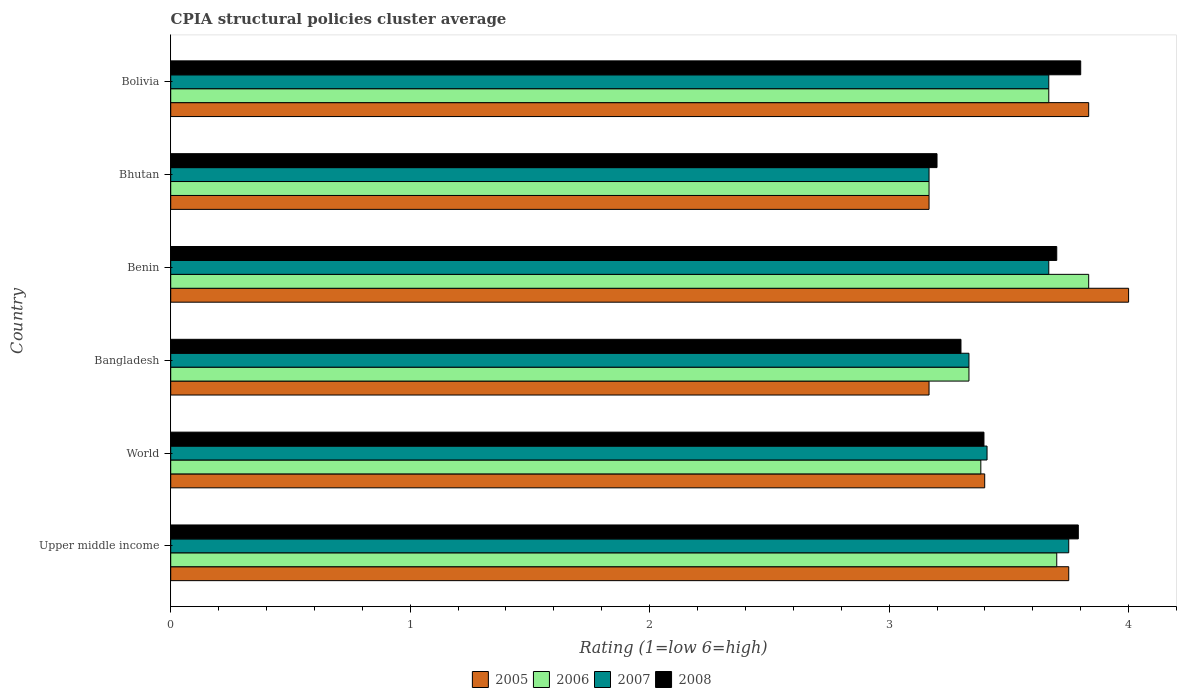How many groups of bars are there?
Offer a very short reply. 6. Are the number of bars on each tick of the Y-axis equal?
Offer a terse response. Yes. How many bars are there on the 5th tick from the top?
Provide a succinct answer. 4. What is the label of the 3rd group of bars from the top?
Give a very brief answer. Benin. In how many cases, is the number of bars for a given country not equal to the number of legend labels?
Your answer should be very brief. 0. What is the CPIA rating in 2005 in Bolivia?
Your answer should be compact. 3.83. Across all countries, what is the maximum CPIA rating in 2007?
Make the answer very short. 3.75. Across all countries, what is the minimum CPIA rating in 2006?
Keep it short and to the point. 3.17. In which country was the CPIA rating in 2006 maximum?
Offer a very short reply. Benin. In which country was the CPIA rating in 2008 minimum?
Offer a very short reply. Bhutan. What is the total CPIA rating in 2008 in the graph?
Ensure brevity in your answer.  21.19. What is the difference between the CPIA rating in 2005 in Bhutan and that in Bolivia?
Ensure brevity in your answer.  -0.67. What is the difference between the CPIA rating in 2007 in Bhutan and the CPIA rating in 2005 in Upper middle income?
Your response must be concise. -0.58. What is the average CPIA rating in 2005 per country?
Provide a short and direct response. 3.55. What is the difference between the CPIA rating in 2006 and CPIA rating in 2008 in World?
Provide a succinct answer. -0.01. What is the ratio of the CPIA rating in 2007 in Bangladesh to that in Bolivia?
Ensure brevity in your answer.  0.91. Is the CPIA rating in 2006 in Bolivia less than that in Upper middle income?
Your response must be concise. Yes. What is the difference between the highest and the second highest CPIA rating in 2008?
Give a very brief answer. 0.01. What is the difference between the highest and the lowest CPIA rating in 2007?
Provide a succinct answer. 0.58. Is the sum of the CPIA rating in 2006 in Bhutan and Bolivia greater than the maximum CPIA rating in 2008 across all countries?
Your response must be concise. Yes. What does the 4th bar from the bottom in Bhutan represents?
Keep it short and to the point. 2008. Are all the bars in the graph horizontal?
Make the answer very short. Yes. How many countries are there in the graph?
Your answer should be very brief. 6. Does the graph contain grids?
Your answer should be very brief. No. What is the title of the graph?
Provide a succinct answer. CPIA structural policies cluster average. What is the Rating (1=low 6=high) in 2005 in Upper middle income?
Provide a succinct answer. 3.75. What is the Rating (1=low 6=high) of 2006 in Upper middle income?
Your response must be concise. 3.7. What is the Rating (1=low 6=high) of 2007 in Upper middle income?
Offer a very short reply. 3.75. What is the Rating (1=low 6=high) in 2008 in Upper middle income?
Keep it short and to the point. 3.79. What is the Rating (1=low 6=high) in 2005 in World?
Offer a terse response. 3.4. What is the Rating (1=low 6=high) of 2006 in World?
Offer a terse response. 3.38. What is the Rating (1=low 6=high) of 2007 in World?
Make the answer very short. 3.41. What is the Rating (1=low 6=high) of 2008 in World?
Give a very brief answer. 3.4. What is the Rating (1=low 6=high) of 2005 in Bangladesh?
Provide a short and direct response. 3.17. What is the Rating (1=low 6=high) in 2006 in Bangladesh?
Provide a short and direct response. 3.33. What is the Rating (1=low 6=high) in 2007 in Bangladesh?
Your answer should be compact. 3.33. What is the Rating (1=low 6=high) in 2005 in Benin?
Your response must be concise. 4. What is the Rating (1=low 6=high) of 2006 in Benin?
Offer a very short reply. 3.83. What is the Rating (1=low 6=high) in 2007 in Benin?
Give a very brief answer. 3.67. What is the Rating (1=low 6=high) in 2008 in Benin?
Your answer should be very brief. 3.7. What is the Rating (1=low 6=high) of 2005 in Bhutan?
Your answer should be very brief. 3.17. What is the Rating (1=low 6=high) of 2006 in Bhutan?
Make the answer very short. 3.17. What is the Rating (1=low 6=high) in 2007 in Bhutan?
Provide a succinct answer. 3.17. What is the Rating (1=low 6=high) of 2005 in Bolivia?
Offer a terse response. 3.83. What is the Rating (1=low 6=high) of 2006 in Bolivia?
Make the answer very short. 3.67. What is the Rating (1=low 6=high) of 2007 in Bolivia?
Your answer should be compact. 3.67. What is the Rating (1=low 6=high) in 2008 in Bolivia?
Give a very brief answer. 3.8. Across all countries, what is the maximum Rating (1=low 6=high) of 2005?
Make the answer very short. 4. Across all countries, what is the maximum Rating (1=low 6=high) in 2006?
Offer a terse response. 3.83. Across all countries, what is the maximum Rating (1=low 6=high) of 2007?
Provide a succinct answer. 3.75. Across all countries, what is the minimum Rating (1=low 6=high) of 2005?
Provide a short and direct response. 3.17. Across all countries, what is the minimum Rating (1=low 6=high) in 2006?
Offer a very short reply. 3.17. Across all countries, what is the minimum Rating (1=low 6=high) of 2007?
Provide a succinct answer. 3.17. Across all countries, what is the minimum Rating (1=low 6=high) in 2008?
Provide a succinct answer. 3.2. What is the total Rating (1=low 6=high) of 2005 in the graph?
Provide a short and direct response. 21.32. What is the total Rating (1=low 6=high) in 2006 in the graph?
Make the answer very short. 21.08. What is the total Rating (1=low 6=high) of 2007 in the graph?
Ensure brevity in your answer.  20.99. What is the total Rating (1=low 6=high) in 2008 in the graph?
Your answer should be very brief. 21.19. What is the difference between the Rating (1=low 6=high) in 2005 in Upper middle income and that in World?
Offer a very short reply. 0.35. What is the difference between the Rating (1=low 6=high) in 2006 in Upper middle income and that in World?
Your answer should be compact. 0.32. What is the difference between the Rating (1=low 6=high) of 2007 in Upper middle income and that in World?
Ensure brevity in your answer.  0.34. What is the difference between the Rating (1=low 6=high) of 2008 in Upper middle income and that in World?
Keep it short and to the point. 0.39. What is the difference between the Rating (1=low 6=high) of 2005 in Upper middle income and that in Bangladesh?
Make the answer very short. 0.58. What is the difference between the Rating (1=low 6=high) of 2006 in Upper middle income and that in Bangladesh?
Ensure brevity in your answer.  0.37. What is the difference between the Rating (1=low 6=high) of 2007 in Upper middle income and that in Bangladesh?
Give a very brief answer. 0.42. What is the difference between the Rating (1=low 6=high) of 2008 in Upper middle income and that in Bangladesh?
Keep it short and to the point. 0.49. What is the difference between the Rating (1=low 6=high) of 2006 in Upper middle income and that in Benin?
Ensure brevity in your answer.  -0.13. What is the difference between the Rating (1=low 6=high) of 2007 in Upper middle income and that in Benin?
Ensure brevity in your answer.  0.08. What is the difference between the Rating (1=low 6=high) of 2008 in Upper middle income and that in Benin?
Keep it short and to the point. 0.09. What is the difference between the Rating (1=low 6=high) in 2005 in Upper middle income and that in Bhutan?
Your answer should be very brief. 0.58. What is the difference between the Rating (1=low 6=high) of 2006 in Upper middle income and that in Bhutan?
Offer a terse response. 0.53. What is the difference between the Rating (1=low 6=high) in 2007 in Upper middle income and that in Bhutan?
Provide a short and direct response. 0.58. What is the difference between the Rating (1=low 6=high) in 2008 in Upper middle income and that in Bhutan?
Give a very brief answer. 0.59. What is the difference between the Rating (1=low 6=high) in 2005 in Upper middle income and that in Bolivia?
Your answer should be compact. -0.08. What is the difference between the Rating (1=low 6=high) of 2007 in Upper middle income and that in Bolivia?
Your answer should be compact. 0.08. What is the difference between the Rating (1=low 6=high) in 2008 in Upper middle income and that in Bolivia?
Make the answer very short. -0.01. What is the difference between the Rating (1=low 6=high) of 2005 in World and that in Bangladesh?
Provide a short and direct response. 0.23. What is the difference between the Rating (1=low 6=high) of 2006 in World and that in Bangladesh?
Keep it short and to the point. 0.05. What is the difference between the Rating (1=low 6=high) in 2007 in World and that in Bangladesh?
Make the answer very short. 0.08. What is the difference between the Rating (1=low 6=high) in 2008 in World and that in Bangladesh?
Provide a succinct answer. 0.1. What is the difference between the Rating (1=low 6=high) of 2005 in World and that in Benin?
Offer a very short reply. -0.6. What is the difference between the Rating (1=low 6=high) in 2006 in World and that in Benin?
Your answer should be compact. -0.45. What is the difference between the Rating (1=low 6=high) in 2007 in World and that in Benin?
Make the answer very short. -0.26. What is the difference between the Rating (1=low 6=high) in 2008 in World and that in Benin?
Make the answer very short. -0.3. What is the difference between the Rating (1=low 6=high) of 2005 in World and that in Bhutan?
Provide a succinct answer. 0.23. What is the difference between the Rating (1=low 6=high) of 2006 in World and that in Bhutan?
Make the answer very short. 0.22. What is the difference between the Rating (1=low 6=high) in 2007 in World and that in Bhutan?
Ensure brevity in your answer.  0.24. What is the difference between the Rating (1=low 6=high) in 2008 in World and that in Bhutan?
Make the answer very short. 0.2. What is the difference between the Rating (1=low 6=high) in 2005 in World and that in Bolivia?
Your response must be concise. -0.43. What is the difference between the Rating (1=low 6=high) in 2006 in World and that in Bolivia?
Offer a very short reply. -0.28. What is the difference between the Rating (1=low 6=high) of 2007 in World and that in Bolivia?
Your answer should be very brief. -0.26. What is the difference between the Rating (1=low 6=high) of 2008 in World and that in Bolivia?
Your answer should be very brief. -0.4. What is the difference between the Rating (1=low 6=high) in 2006 in Bangladesh and that in Benin?
Offer a very short reply. -0.5. What is the difference between the Rating (1=low 6=high) in 2006 in Bangladesh and that in Bhutan?
Provide a short and direct response. 0.17. What is the difference between the Rating (1=low 6=high) in 2007 in Bangladesh and that in Bhutan?
Keep it short and to the point. 0.17. What is the difference between the Rating (1=low 6=high) in 2008 in Bangladesh and that in Bhutan?
Your answer should be compact. 0.1. What is the difference between the Rating (1=low 6=high) of 2005 in Benin and that in Bhutan?
Make the answer very short. 0.83. What is the difference between the Rating (1=low 6=high) of 2007 in Benin and that in Bhutan?
Your answer should be compact. 0.5. What is the difference between the Rating (1=low 6=high) in 2008 in Benin and that in Bhutan?
Keep it short and to the point. 0.5. What is the difference between the Rating (1=low 6=high) of 2005 in Benin and that in Bolivia?
Your answer should be very brief. 0.17. What is the difference between the Rating (1=low 6=high) in 2007 in Benin and that in Bolivia?
Offer a very short reply. 0. What is the difference between the Rating (1=low 6=high) in 2005 in Bhutan and that in Bolivia?
Offer a terse response. -0.67. What is the difference between the Rating (1=low 6=high) of 2006 in Bhutan and that in Bolivia?
Provide a short and direct response. -0.5. What is the difference between the Rating (1=low 6=high) in 2008 in Bhutan and that in Bolivia?
Provide a short and direct response. -0.6. What is the difference between the Rating (1=low 6=high) of 2005 in Upper middle income and the Rating (1=low 6=high) of 2006 in World?
Your answer should be very brief. 0.37. What is the difference between the Rating (1=low 6=high) of 2005 in Upper middle income and the Rating (1=low 6=high) of 2007 in World?
Your response must be concise. 0.34. What is the difference between the Rating (1=low 6=high) in 2005 in Upper middle income and the Rating (1=low 6=high) in 2008 in World?
Your response must be concise. 0.35. What is the difference between the Rating (1=low 6=high) in 2006 in Upper middle income and the Rating (1=low 6=high) in 2007 in World?
Your answer should be compact. 0.29. What is the difference between the Rating (1=low 6=high) in 2006 in Upper middle income and the Rating (1=low 6=high) in 2008 in World?
Ensure brevity in your answer.  0.3. What is the difference between the Rating (1=low 6=high) in 2007 in Upper middle income and the Rating (1=low 6=high) in 2008 in World?
Offer a very short reply. 0.35. What is the difference between the Rating (1=low 6=high) of 2005 in Upper middle income and the Rating (1=low 6=high) of 2006 in Bangladesh?
Make the answer very short. 0.42. What is the difference between the Rating (1=low 6=high) of 2005 in Upper middle income and the Rating (1=low 6=high) of 2007 in Bangladesh?
Keep it short and to the point. 0.42. What is the difference between the Rating (1=low 6=high) of 2005 in Upper middle income and the Rating (1=low 6=high) of 2008 in Bangladesh?
Provide a succinct answer. 0.45. What is the difference between the Rating (1=low 6=high) of 2006 in Upper middle income and the Rating (1=low 6=high) of 2007 in Bangladesh?
Your answer should be compact. 0.37. What is the difference between the Rating (1=low 6=high) in 2006 in Upper middle income and the Rating (1=low 6=high) in 2008 in Bangladesh?
Your answer should be very brief. 0.4. What is the difference between the Rating (1=low 6=high) of 2007 in Upper middle income and the Rating (1=low 6=high) of 2008 in Bangladesh?
Provide a short and direct response. 0.45. What is the difference between the Rating (1=low 6=high) of 2005 in Upper middle income and the Rating (1=low 6=high) of 2006 in Benin?
Make the answer very short. -0.08. What is the difference between the Rating (1=low 6=high) in 2005 in Upper middle income and the Rating (1=low 6=high) in 2007 in Benin?
Offer a terse response. 0.08. What is the difference between the Rating (1=low 6=high) of 2006 in Upper middle income and the Rating (1=low 6=high) of 2007 in Benin?
Provide a short and direct response. 0.03. What is the difference between the Rating (1=low 6=high) in 2006 in Upper middle income and the Rating (1=low 6=high) in 2008 in Benin?
Make the answer very short. 0. What is the difference between the Rating (1=low 6=high) of 2005 in Upper middle income and the Rating (1=low 6=high) of 2006 in Bhutan?
Keep it short and to the point. 0.58. What is the difference between the Rating (1=low 6=high) of 2005 in Upper middle income and the Rating (1=low 6=high) of 2007 in Bhutan?
Make the answer very short. 0.58. What is the difference between the Rating (1=low 6=high) in 2005 in Upper middle income and the Rating (1=low 6=high) in 2008 in Bhutan?
Your answer should be very brief. 0.55. What is the difference between the Rating (1=low 6=high) of 2006 in Upper middle income and the Rating (1=low 6=high) of 2007 in Bhutan?
Ensure brevity in your answer.  0.53. What is the difference between the Rating (1=low 6=high) of 2007 in Upper middle income and the Rating (1=low 6=high) of 2008 in Bhutan?
Your answer should be compact. 0.55. What is the difference between the Rating (1=low 6=high) in 2005 in Upper middle income and the Rating (1=low 6=high) in 2006 in Bolivia?
Make the answer very short. 0.08. What is the difference between the Rating (1=low 6=high) in 2005 in Upper middle income and the Rating (1=low 6=high) in 2007 in Bolivia?
Provide a succinct answer. 0.08. What is the difference between the Rating (1=low 6=high) of 2006 in Upper middle income and the Rating (1=low 6=high) of 2008 in Bolivia?
Provide a succinct answer. -0.1. What is the difference between the Rating (1=low 6=high) in 2007 in Upper middle income and the Rating (1=low 6=high) in 2008 in Bolivia?
Your answer should be compact. -0.05. What is the difference between the Rating (1=low 6=high) in 2005 in World and the Rating (1=low 6=high) in 2006 in Bangladesh?
Keep it short and to the point. 0.07. What is the difference between the Rating (1=low 6=high) of 2005 in World and the Rating (1=low 6=high) of 2007 in Bangladesh?
Offer a very short reply. 0.07. What is the difference between the Rating (1=low 6=high) in 2005 in World and the Rating (1=low 6=high) in 2008 in Bangladesh?
Your answer should be compact. 0.1. What is the difference between the Rating (1=low 6=high) of 2006 in World and the Rating (1=low 6=high) of 2007 in Bangladesh?
Make the answer very short. 0.05. What is the difference between the Rating (1=low 6=high) of 2006 in World and the Rating (1=low 6=high) of 2008 in Bangladesh?
Your response must be concise. 0.08. What is the difference between the Rating (1=low 6=high) in 2007 in World and the Rating (1=low 6=high) in 2008 in Bangladesh?
Offer a very short reply. 0.11. What is the difference between the Rating (1=low 6=high) in 2005 in World and the Rating (1=low 6=high) in 2006 in Benin?
Provide a succinct answer. -0.43. What is the difference between the Rating (1=low 6=high) in 2005 in World and the Rating (1=low 6=high) in 2007 in Benin?
Your answer should be compact. -0.27. What is the difference between the Rating (1=low 6=high) in 2005 in World and the Rating (1=low 6=high) in 2008 in Benin?
Your response must be concise. -0.3. What is the difference between the Rating (1=low 6=high) in 2006 in World and the Rating (1=low 6=high) in 2007 in Benin?
Provide a succinct answer. -0.28. What is the difference between the Rating (1=low 6=high) in 2006 in World and the Rating (1=low 6=high) in 2008 in Benin?
Keep it short and to the point. -0.32. What is the difference between the Rating (1=low 6=high) of 2007 in World and the Rating (1=low 6=high) of 2008 in Benin?
Provide a short and direct response. -0.29. What is the difference between the Rating (1=low 6=high) of 2005 in World and the Rating (1=low 6=high) of 2006 in Bhutan?
Keep it short and to the point. 0.23. What is the difference between the Rating (1=low 6=high) of 2005 in World and the Rating (1=low 6=high) of 2007 in Bhutan?
Provide a succinct answer. 0.23. What is the difference between the Rating (1=low 6=high) in 2005 in World and the Rating (1=low 6=high) in 2008 in Bhutan?
Make the answer very short. 0.2. What is the difference between the Rating (1=low 6=high) of 2006 in World and the Rating (1=low 6=high) of 2007 in Bhutan?
Give a very brief answer. 0.22. What is the difference between the Rating (1=low 6=high) in 2006 in World and the Rating (1=low 6=high) in 2008 in Bhutan?
Your answer should be compact. 0.18. What is the difference between the Rating (1=low 6=high) of 2007 in World and the Rating (1=low 6=high) of 2008 in Bhutan?
Offer a very short reply. 0.21. What is the difference between the Rating (1=low 6=high) of 2005 in World and the Rating (1=low 6=high) of 2006 in Bolivia?
Your response must be concise. -0.27. What is the difference between the Rating (1=low 6=high) of 2005 in World and the Rating (1=low 6=high) of 2007 in Bolivia?
Give a very brief answer. -0.27. What is the difference between the Rating (1=low 6=high) in 2005 in World and the Rating (1=low 6=high) in 2008 in Bolivia?
Provide a short and direct response. -0.4. What is the difference between the Rating (1=low 6=high) in 2006 in World and the Rating (1=low 6=high) in 2007 in Bolivia?
Make the answer very short. -0.28. What is the difference between the Rating (1=low 6=high) in 2006 in World and the Rating (1=low 6=high) in 2008 in Bolivia?
Ensure brevity in your answer.  -0.42. What is the difference between the Rating (1=low 6=high) in 2007 in World and the Rating (1=low 6=high) in 2008 in Bolivia?
Offer a terse response. -0.39. What is the difference between the Rating (1=low 6=high) in 2005 in Bangladesh and the Rating (1=low 6=high) in 2006 in Benin?
Give a very brief answer. -0.67. What is the difference between the Rating (1=low 6=high) in 2005 in Bangladesh and the Rating (1=low 6=high) in 2008 in Benin?
Offer a very short reply. -0.53. What is the difference between the Rating (1=low 6=high) of 2006 in Bangladesh and the Rating (1=low 6=high) of 2008 in Benin?
Keep it short and to the point. -0.37. What is the difference between the Rating (1=low 6=high) in 2007 in Bangladesh and the Rating (1=low 6=high) in 2008 in Benin?
Your answer should be compact. -0.37. What is the difference between the Rating (1=low 6=high) in 2005 in Bangladesh and the Rating (1=low 6=high) in 2006 in Bhutan?
Ensure brevity in your answer.  0. What is the difference between the Rating (1=low 6=high) in 2005 in Bangladesh and the Rating (1=low 6=high) in 2008 in Bhutan?
Offer a terse response. -0.03. What is the difference between the Rating (1=low 6=high) in 2006 in Bangladesh and the Rating (1=low 6=high) in 2008 in Bhutan?
Offer a very short reply. 0.13. What is the difference between the Rating (1=low 6=high) of 2007 in Bangladesh and the Rating (1=low 6=high) of 2008 in Bhutan?
Make the answer very short. 0.13. What is the difference between the Rating (1=low 6=high) of 2005 in Bangladesh and the Rating (1=low 6=high) of 2008 in Bolivia?
Provide a short and direct response. -0.63. What is the difference between the Rating (1=low 6=high) in 2006 in Bangladesh and the Rating (1=low 6=high) in 2007 in Bolivia?
Offer a terse response. -0.33. What is the difference between the Rating (1=low 6=high) in 2006 in Bangladesh and the Rating (1=low 6=high) in 2008 in Bolivia?
Provide a succinct answer. -0.47. What is the difference between the Rating (1=low 6=high) of 2007 in Bangladesh and the Rating (1=low 6=high) of 2008 in Bolivia?
Give a very brief answer. -0.47. What is the difference between the Rating (1=low 6=high) of 2005 in Benin and the Rating (1=low 6=high) of 2006 in Bhutan?
Your answer should be compact. 0.83. What is the difference between the Rating (1=low 6=high) in 2006 in Benin and the Rating (1=low 6=high) in 2008 in Bhutan?
Provide a succinct answer. 0.63. What is the difference between the Rating (1=low 6=high) in 2007 in Benin and the Rating (1=low 6=high) in 2008 in Bhutan?
Offer a very short reply. 0.47. What is the difference between the Rating (1=low 6=high) in 2005 in Benin and the Rating (1=low 6=high) in 2006 in Bolivia?
Offer a very short reply. 0.33. What is the difference between the Rating (1=low 6=high) of 2005 in Benin and the Rating (1=low 6=high) of 2007 in Bolivia?
Provide a short and direct response. 0.33. What is the difference between the Rating (1=low 6=high) in 2005 in Benin and the Rating (1=low 6=high) in 2008 in Bolivia?
Make the answer very short. 0.2. What is the difference between the Rating (1=low 6=high) in 2006 in Benin and the Rating (1=low 6=high) in 2008 in Bolivia?
Provide a succinct answer. 0.03. What is the difference between the Rating (1=low 6=high) in 2007 in Benin and the Rating (1=low 6=high) in 2008 in Bolivia?
Ensure brevity in your answer.  -0.13. What is the difference between the Rating (1=low 6=high) in 2005 in Bhutan and the Rating (1=low 6=high) in 2008 in Bolivia?
Give a very brief answer. -0.63. What is the difference between the Rating (1=low 6=high) in 2006 in Bhutan and the Rating (1=low 6=high) in 2008 in Bolivia?
Give a very brief answer. -0.63. What is the difference between the Rating (1=low 6=high) of 2007 in Bhutan and the Rating (1=low 6=high) of 2008 in Bolivia?
Your answer should be compact. -0.63. What is the average Rating (1=low 6=high) in 2005 per country?
Give a very brief answer. 3.55. What is the average Rating (1=low 6=high) in 2006 per country?
Make the answer very short. 3.51. What is the average Rating (1=low 6=high) of 2007 per country?
Provide a succinct answer. 3.5. What is the average Rating (1=low 6=high) in 2008 per country?
Your answer should be very brief. 3.53. What is the difference between the Rating (1=low 6=high) in 2005 and Rating (1=low 6=high) in 2006 in Upper middle income?
Your answer should be very brief. 0.05. What is the difference between the Rating (1=low 6=high) of 2005 and Rating (1=low 6=high) of 2008 in Upper middle income?
Offer a very short reply. -0.04. What is the difference between the Rating (1=low 6=high) in 2006 and Rating (1=low 6=high) in 2007 in Upper middle income?
Your response must be concise. -0.05. What is the difference between the Rating (1=low 6=high) of 2006 and Rating (1=low 6=high) of 2008 in Upper middle income?
Offer a terse response. -0.09. What is the difference between the Rating (1=low 6=high) in 2007 and Rating (1=low 6=high) in 2008 in Upper middle income?
Offer a very short reply. -0.04. What is the difference between the Rating (1=low 6=high) in 2005 and Rating (1=low 6=high) in 2006 in World?
Offer a very short reply. 0.02. What is the difference between the Rating (1=low 6=high) in 2005 and Rating (1=low 6=high) in 2007 in World?
Make the answer very short. -0.01. What is the difference between the Rating (1=low 6=high) in 2005 and Rating (1=low 6=high) in 2008 in World?
Provide a succinct answer. 0. What is the difference between the Rating (1=low 6=high) in 2006 and Rating (1=low 6=high) in 2007 in World?
Offer a very short reply. -0.03. What is the difference between the Rating (1=low 6=high) in 2006 and Rating (1=low 6=high) in 2008 in World?
Provide a succinct answer. -0.01. What is the difference between the Rating (1=low 6=high) of 2007 and Rating (1=low 6=high) of 2008 in World?
Your response must be concise. 0.01. What is the difference between the Rating (1=low 6=high) in 2005 and Rating (1=low 6=high) in 2006 in Bangladesh?
Your response must be concise. -0.17. What is the difference between the Rating (1=low 6=high) in 2005 and Rating (1=low 6=high) in 2008 in Bangladesh?
Offer a very short reply. -0.13. What is the difference between the Rating (1=low 6=high) of 2006 and Rating (1=low 6=high) of 2008 in Bangladesh?
Provide a succinct answer. 0.03. What is the difference between the Rating (1=low 6=high) of 2007 and Rating (1=low 6=high) of 2008 in Bangladesh?
Your response must be concise. 0.03. What is the difference between the Rating (1=low 6=high) of 2005 and Rating (1=low 6=high) of 2006 in Benin?
Offer a terse response. 0.17. What is the difference between the Rating (1=low 6=high) in 2005 and Rating (1=low 6=high) in 2007 in Benin?
Your answer should be compact. 0.33. What is the difference between the Rating (1=low 6=high) of 2005 and Rating (1=low 6=high) of 2008 in Benin?
Your answer should be compact. 0.3. What is the difference between the Rating (1=low 6=high) in 2006 and Rating (1=low 6=high) in 2008 in Benin?
Your answer should be compact. 0.13. What is the difference between the Rating (1=low 6=high) in 2007 and Rating (1=low 6=high) in 2008 in Benin?
Offer a very short reply. -0.03. What is the difference between the Rating (1=low 6=high) in 2005 and Rating (1=low 6=high) in 2007 in Bhutan?
Keep it short and to the point. 0. What is the difference between the Rating (1=low 6=high) in 2005 and Rating (1=low 6=high) in 2008 in Bhutan?
Make the answer very short. -0.03. What is the difference between the Rating (1=low 6=high) in 2006 and Rating (1=low 6=high) in 2007 in Bhutan?
Offer a very short reply. 0. What is the difference between the Rating (1=low 6=high) in 2006 and Rating (1=low 6=high) in 2008 in Bhutan?
Your response must be concise. -0.03. What is the difference between the Rating (1=low 6=high) in 2007 and Rating (1=low 6=high) in 2008 in Bhutan?
Your answer should be very brief. -0.03. What is the difference between the Rating (1=low 6=high) in 2005 and Rating (1=low 6=high) in 2007 in Bolivia?
Offer a terse response. 0.17. What is the difference between the Rating (1=low 6=high) of 2006 and Rating (1=low 6=high) of 2008 in Bolivia?
Offer a very short reply. -0.13. What is the difference between the Rating (1=low 6=high) in 2007 and Rating (1=low 6=high) in 2008 in Bolivia?
Give a very brief answer. -0.13. What is the ratio of the Rating (1=low 6=high) of 2005 in Upper middle income to that in World?
Provide a short and direct response. 1.1. What is the ratio of the Rating (1=low 6=high) of 2006 in Upper middle income to that in World?
Your answer should be very brief. 1.09. What is the ratio of the Rating (1=low 6=high) in 2007 in Upper middle income to that in World?
Give a very brief answer. 1.1. What is the ratio of the Rating (1=low 6=high) of 2008 in Upper middle income to that in World?
Make the answer very short. 1.12. What is the ratio of the Rating (1=low 6=high) of 2005 in Upper middle income to that in Bangladesh?
Ensure brevity in your answer.  1.18. What is the ratio of the Rating (1=low 6=high) of 2006 in Upper middle income to that in Bangladesh?
Offer a terse response. 1.11. What is the ratio of the Rating (1=low 6=high) of 2008 in Upper middle income to that in Bangladesh?
Give a very brief answer. 1.15. What is the ratio of the Rating (1=low 6=high) in 2005 in Upper middle income to that in Benin?
Your response must be concise. 0.94. What is the ratio of the Rating (1=low 6=high) in 2006 in Upper middle income to that in Benin?
Give a very brief answer. 0.97. What is the ratio of the Rating (1=low 6=high) of 2007 in Upper middle income to that in Benin?
Keep it short and to the point. 1.02. What is the ratio of the Rating (1=low 6=high) of 2008 in Upper middle income to that in Benin?
Your answer should be very brief. 1.02. What is the ratio of the Rating (1=low 6=high) of 2005 in Upper middle income to that in Bhutan?
Your response must be concise. 1.18. What is the ratio of the Rating (1=low 6=high) of 2006 in Upper middle income to that in Bhutan?
Provide a succinct answer. 1.17. What is the ratio of the Rating (1=low 6=high) of 2007 in Upper middle income to that in Bhutan?
Give a very brief answer. 1.18. What is the ratio of the Rating (1=low 6=high) of 2008 in Upper middle income to that in Bhutan?
Provide a short and direct response. 1.18. What is the ratio of the Rating (1=low 6=high) in 2005 in Upper middle income to that in Bolivia?
Make the answer very short. 0.98. What is the ratio of the Rating (1=low 6=high) of 2006 in Upper middle income to that in Bolivia?
Keep it short and to the point. 1.01. What is the ratio of the Rating (1=low 6=high) of 2007 in Upper middle income to that in Bolivia?
Your answer should be very brief. 1.02. What is the ratio of the Rating (1=low 6=high) in 2005 in World to that in Bangladesh?
Make the answer very short. 1.07. What is the ratio of the Rating (1=low 6=high) of 2006 in World to that in Bangladesh?
Keep it short and to the point. 1.01. What is the ratio of the Rating (1=low 6=high) of 2007 in World to that in Bangladesh?
Your answer should be compact. 1.02. What is the ratio of the Rating (1=low 6=high) in 2008 in World to that in Bangladesh?
Your answer should be compact. 1.03. What is the ratio of the Rating (1=low 6=high) in 2005 in World to that in Benin?
Give a very brief answer. 0.85. What is the ratio of the Rating (1=low 6=high) of 2006 in World to that in Benin?
Make the answer very short. 0.88. What is the ratio of the Rating (1=low 6=high) in 2007 in World to that in Benin?
Your answer should be very brief. 0.93. What is the ratio of the Rating (1=low 6=high) of 2008 in World to that in Benin?
Provide a succinct answer. 0.92. What is the ratio of the Rating (1=low 6=high) in 2005 in World to that in Bhutan?
Give a very brief answer. 1.07. What is the ratio of the Rating (1=low 6=high) in 2006 in World to that in Bhutan?
Ensure brevity in your answer.  1.07. What is the ratio of the Rating (1=low 6=high) in 2007 in World to that in Bhutan?
Offer a very short reply. 1.08. What is the ratio of the Rating (1=low 6=high) in 2008 in World to that in Bhutan?
Provide a succinct answer. 1.06. What is the ratio of the Rating (1=low 6=high) of 2005 in World to that in Bolivia?
Provide a succinct answer. 0.89. What is the ratio of the Rating (1=low 6=high) in 2006 in World to that in Bolivia?
Offer a very short reply. 0.92. What is the ratio of the Rating (1=low 6=high) in 2007 in World to that in Bolivia?
Your answer should be very brief. 0.93. What is the ratio of the Rating (1=low 6=high) of 2008 in World to that in Bolivia?
Your answer should be very brief. 0.89. What is the ratio of the Rating (1=low 6=high) in 2005 in Bangladesh to that in Benin?
Make the answer very short. 0.79. What is the ratio of the Rating (1=low 6=high) of 2006 in Bangladesh to that in Benin?
Make the answer very short. 0.87. What is the ratio of the Rating (1=low 6=high) of 2008 in Bangladesh to that in Benin?
Provide a short and direct response. 0.89. What is the ratio of the Rating (1=low 6=high) of 2005 in Bangladesh to that in Bhutan?
Offer a very short reply. 1. What is the ratio of the Rating (1=low 6=high) of 2006 in Bangladesh to that in Bhutan?
Provide a short and direct response. 1.05. What is the ratio of the Rating (1=low 6=high) in 2007 in Bangladesh to that in Bhutan?
Your response must be concise. 1.05. What is the ratio of the Rating (1=low 6=high) in 2008 in Bangladesh to that in Bhutan?
Provide a succinct answer. 1.03. What is the ratio of the Rating (1=low 6=high) of 2005 in Bangladesh to that in Bolivia?
Offer a very short reply. 0.83. What is the ratio of the Rating (1=low 6=high) of 2007 in Bangladesh to that in Bolivia?
Your answer should be very brief. 0.91. What is the ratio of the Rating (1=low 6=high) of 2008 in Bangladesh to that in Bolivia?
Provide a short and direct response. 0.87. What is the ratio of the Rating (1=low 6=high) in 2005 in Benin to that in Bhutan?
Provide a short and direct response. 1.26. What is the ratio of the Rating (1=low 6=high) of 2006 in Benin to that in Bhutan?
Offer a terse response. 1.21. What is the ratio of the Rating (1=low 6=high) in 2007 in Benin to that in Bhutan?
Provide a succinct answer. 1.16. What is the ratio of the Rating (1=low 6=high) in 2008 in Benin to that in Bhutan?
Your response must be concise. 1.16. What is the ratio of the Rating (1=low 6=high) in 2005 in Benin to that in Bolivia?
Ensure brevity in your answer.  1.04. What is the ratio of the Rating (1=low 6=high) of 2006 in Benin to that in Bolivia?
Offer a terse response. 1.05. What is the ratio of the Rating (1=low 6=high) of 2007 in Benin to that in Bolivia?
Your response must be concise. 1. What is the ratio of the Rating (1=low 6=high) in 2008 in Benin to that in Bolivia?
Make the answer very short. 0.97. What is the ratio of the Rating (1=low 6=high) of 2005 in Bhutan to that in Bolivia?
Your answer should be very brief. 0.83. What is the ratio of the Rating (1=low 6=high) in 2006 in Bhutan to that in Bolivia?
Give a very brief answer. 0.86. What is the ratio of the Rating (1=low 6=high) in 2007 in Bhutan to that in Bolivia?
Your answer should be very brief. 0.86. What is the ratio of the Rating (1=low 6=high) of 2008 in Bhutan to that in Bolivia?
Your response must be concise. 0.84. What is the difference between the highest and the second highest Rating (1=low 6=high) in 2005?
Offer a terse response. 0.17. What is the difference between the highest and the second highest Rating (1=low 6=high) in 2006?
Offer a terse response. 0.13. What is the difference between the highest and the second highest Rating (1=low 6=high) in 2007?
Keep it short and to the point. 0.08. What is the difference between the highest and the second highest Rating (1=low 6=high) in 2008?
Give a very brief answer. 0.01. What is the difference between the highest and the lowest Rating (1=low 6=high) of 2006?
Keep it short and to the point. 0.67. What is the difference between the highest and the lowest Rating (1=low 6=high) in 2007?
Provide a short and direct response. 0.58. What is the difference between the highest and the lowest Rating (1=low 6=high) in 2008?
Provide a succinct answer. 0.6. 